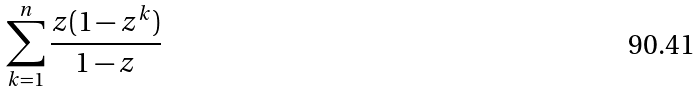Convert formula to latex. <formula><loc_0><loc_0><loc_500><loc_500>\sum _ { k = 1 } ^ { n } \frac { z ( 1 - z ^ { k } ) } { 1 - z }</formula> 